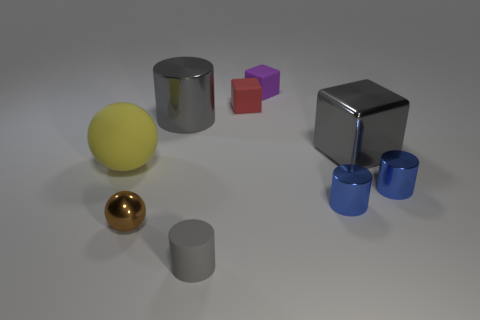There is a big cylinder that is the same color as the big metal block; what is its material?
Offer a terse response. Metal. Are there any large things that have the same color as the big cube?
Give a very brief answer. Yes. Do the metal cube and the big cylinder have the same color?
Give a very brief answer. Yes. How big is the sphere that is to the right of the matte sphere?
Keep it short and to the point. Small. Is the large gray cylinder made of the same material as the tiny brown object?
Offer a terse response. Yes. The tiny brown object that is made of the same material as the large gray cube is what shape?
Provide a succinct answer. Sphere. Is there anything else of the same color as the small metallic sphere?
Offer a terse response. No. What color is the big object that is to the right of the small gray cylinder?
Provide a short and direct response. Gray. There is a tiny rubber object that is in front of the big shiny cube; does it have the same color as the big metallic cylinder?
Make the answer very short. Yes. There is a large gray thing that is the same shape as the red matte thing; what is its material?
Provide a succinct answer. Metal. 